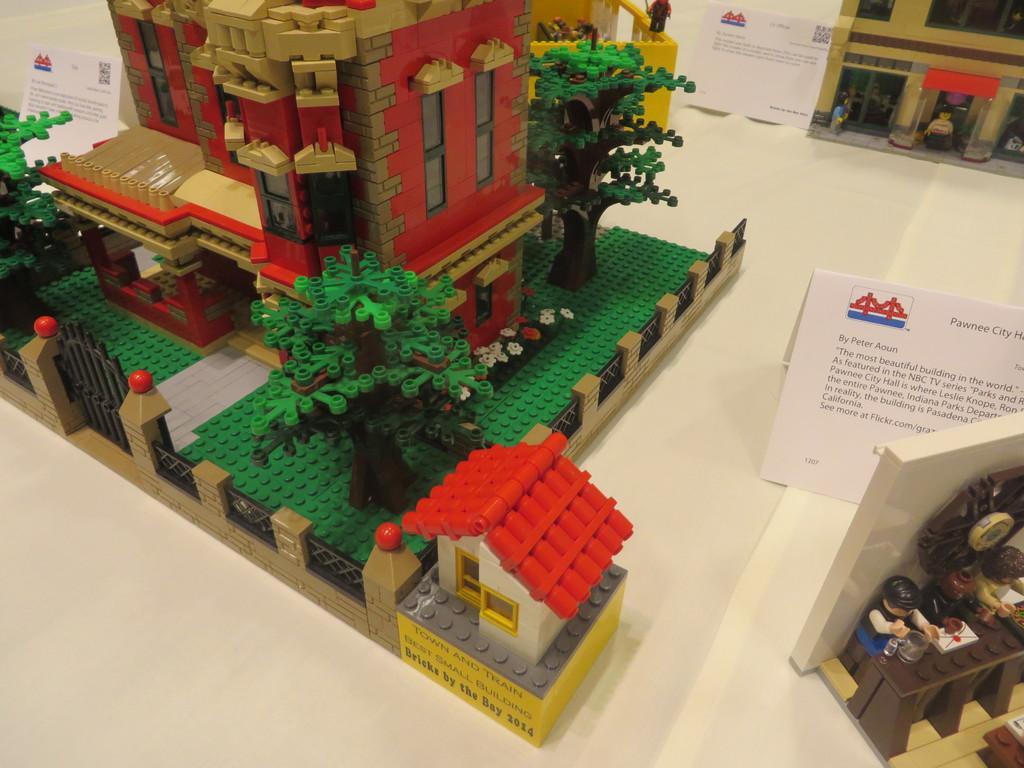In one or two sentences, can you explain what this image depicts? This image consists of a miniature of a building along with the trees. And we can see the cards beside the miniatures. On the right, there are more two miniatures are kept on the desk. 